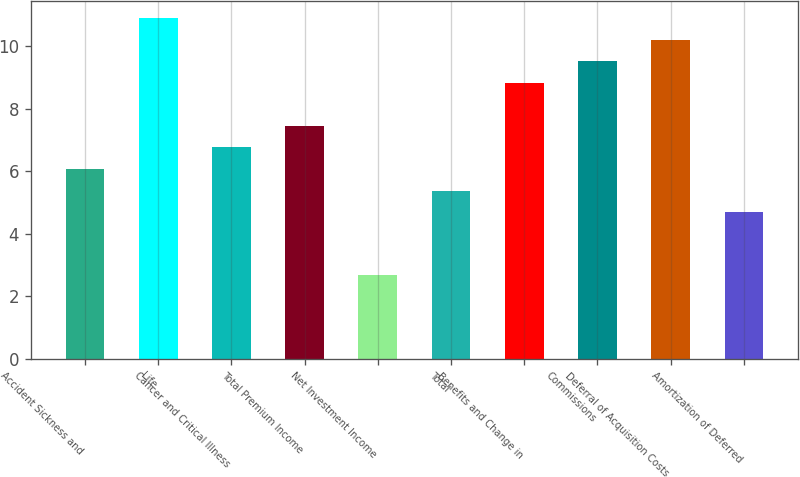Convert chart to OTSL. <chart><loc_0><loc_0><loc_500><loc_500><bar_chart><fcel>Accident Sickness and<fcel>Life<fcel>Cancer and Critical Illness<fcel>Total Premium Income<fcel>Net Investment Income<fcel>Total<fcel>Benefits and Change in<fcel>Commissions<fcel>Deferral of Acquisition Costs<fcel>Amortization of Deferred<nl><fcel>6.08<fcel>10.91<fcel>6.77<fcel>7.46<fcel>2.7<fcel>5.39<fcel>8.84<fcel>9.53<fcel>10.22<fcel>4.7<nl></chart> 